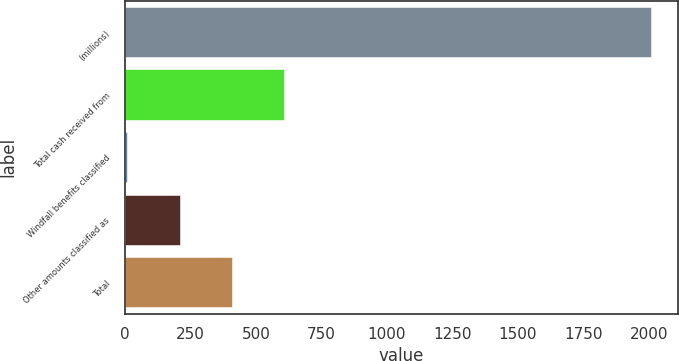Convert chart. <chart><loc_0><loc_0><loc_500><loc_500><bar_chart><fcel>(millions)<fcel>Total cash received from<fcel>Windfall benefits classified<fcel>Other amounts classified as<fcel>Total<nl><fcel>2010<fcel>608.6<fcel>8<fcel>208.2<fcel>408.4<nl></chart> 